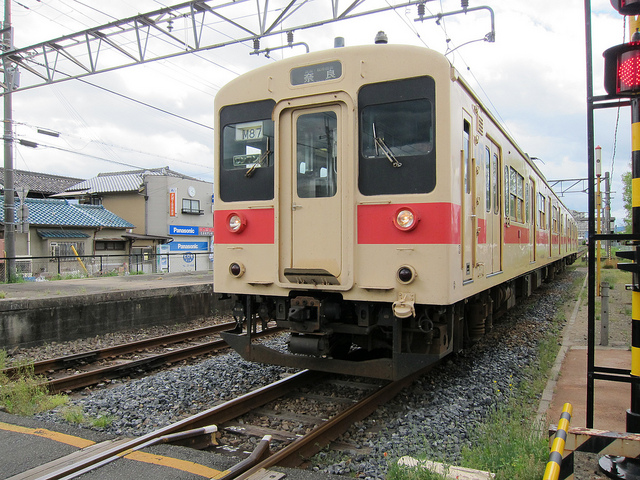Read and extract the text from this image. Panasonic 